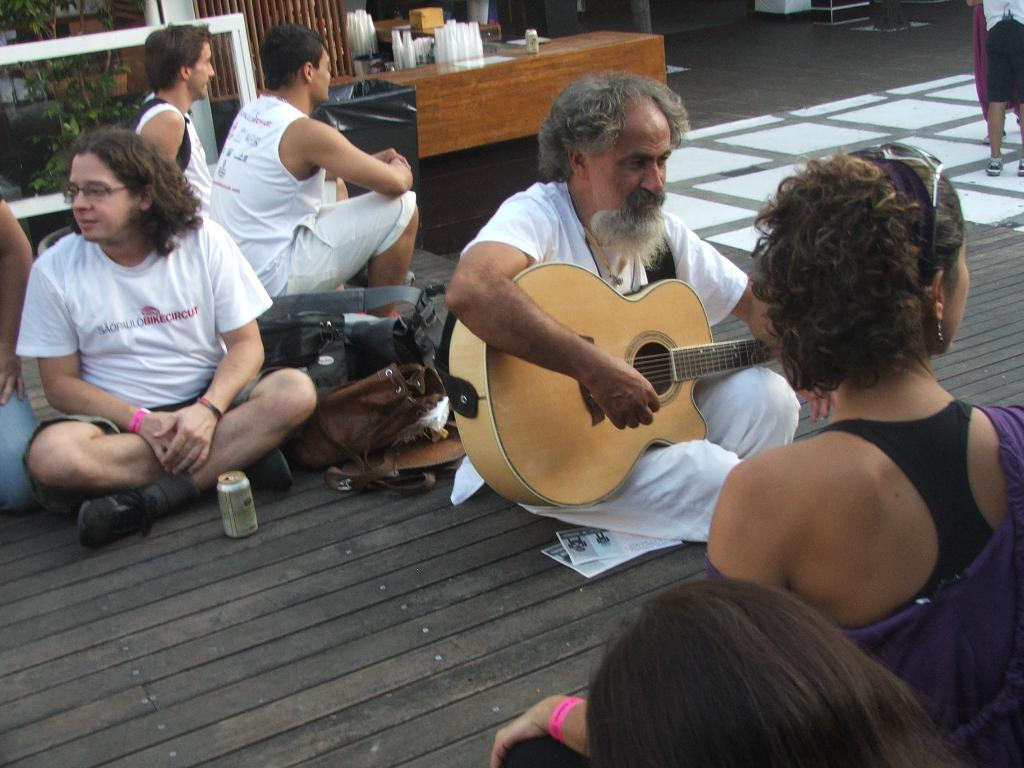What are the people in the image doing? The people in the image are sitting. What activity is the man engaged in? The man is playing guitar. What piece of furniture is present in the image? There is a table in the image. What objects can be seen on the table? There are glasses on the table. What type of vegetation is present in the image? There are plants in the image. What type of knife is the daughter using to cut the cake in the image? There is no daughter or cake present in the image, so it is not possible to answer that question. 